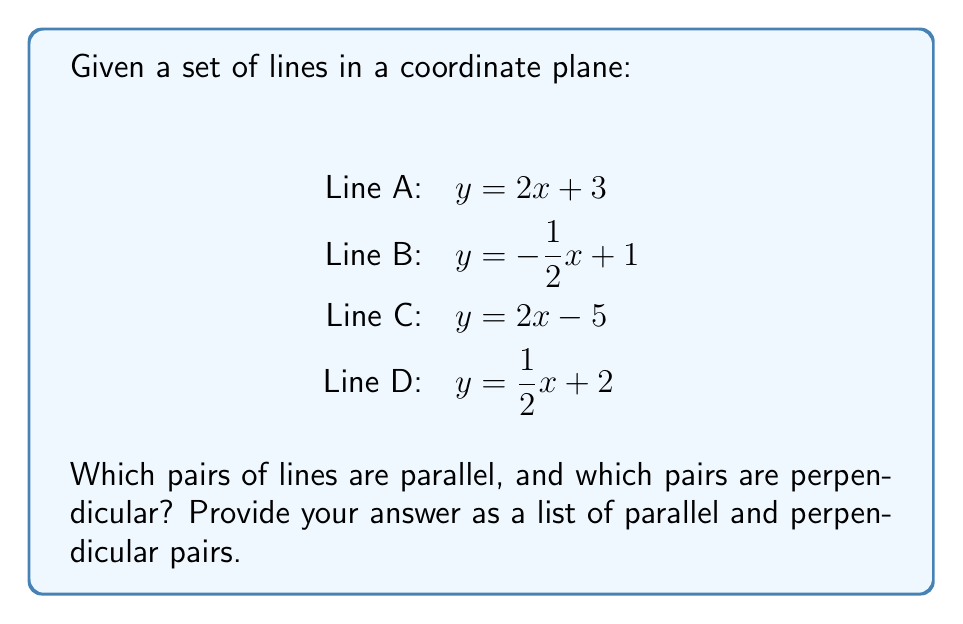Show me your answer to this math problem. To identify parallel and perpendicular lines, we need to compare their slopes:

1. Parallel lines have the same slope.
2. Perpendicular lines have slopes that are negative reciprocals of each other.

Let's extract the slopes from each line equation:

Line A: $m_A = 2$
Line B: $m_B = -\frac{1}{2}$
Line C: $m_C = 2$
Line D: $m_D = \frac{1}{2}$

Now, let's compare the slopes:

1. Parallel lines:
   - Lines A and C have the same slope (2), so they are parallel.

2. Perpendicular lines:
   - The slope of Line A ($2$) is the negative reciprocal of Line B's slope ($-\frac{1}{2}$), so they are perpendicular.
   - The slope of Line C ($2$) is also the negative reciprocal of Line B's slope ($-\frac{1}{2}$), so they are perpendicular.

No other pairs of lines are parallel or perpendicular.
Answer: Parallel: A and C; Perpendicular: A and B, B and C 